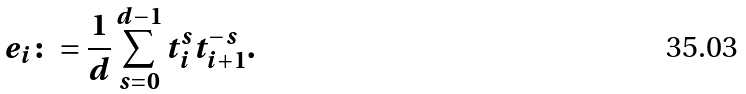<formula> <loc_0><loc_0><loc_500><loc_500>e _ { i } \colon = \frac { 1 } { d } \sum _ { s = 0 } ^ { d - 1 } t _ { i } ^ { s } t _ { i + 1 } ^ { - s } .</formula> 